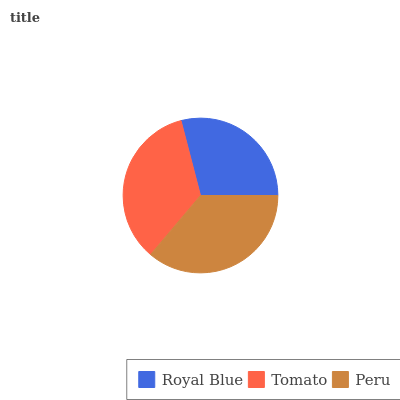Is Royal Blue the minimum?
Answer yes or no. Yes. Is Peru the maximum?
Answer yes or no. Yes. Is Tomato the minimum?
Answer yes or no. No. Is Tomato the maximum?
Answer yes or no. No. Is Tomato greater than Royal Blue?
Answer yes or no. Yes. Is Royal Blue less than Tomato?
Answer yes or no. Yes. Is Royal Blue greater than Tomato?
Answer yes or no. No. Is Tomato less than Royal Blue?
Answer yes or no. No. Is Tomato the high median?
Answer yes or no. Yes. Is Tomato the low median?
Answer yes or no. Yes. Is Royal Blue the high median?
Answer yes or no. No. Is Royal Blue the low median?
Answer yes or no. No. 